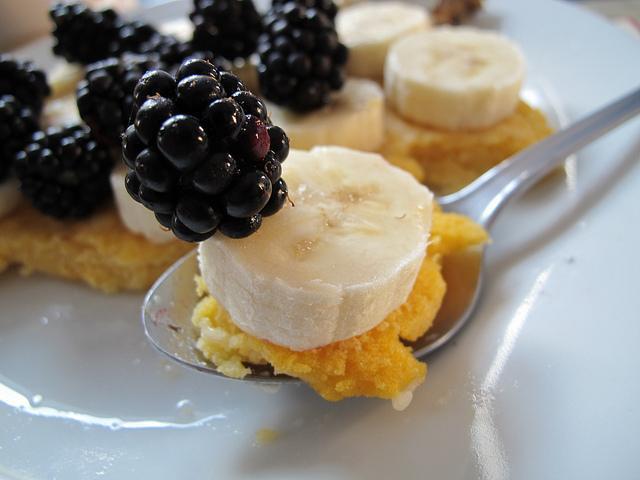What type of fruit is at the very top of the scoop with the banana and oat?
Select the accurate response from the four choices given to answer the question.
Options: Cantaloupe, raspberry, blackberry, strawberry. Blackberry. 